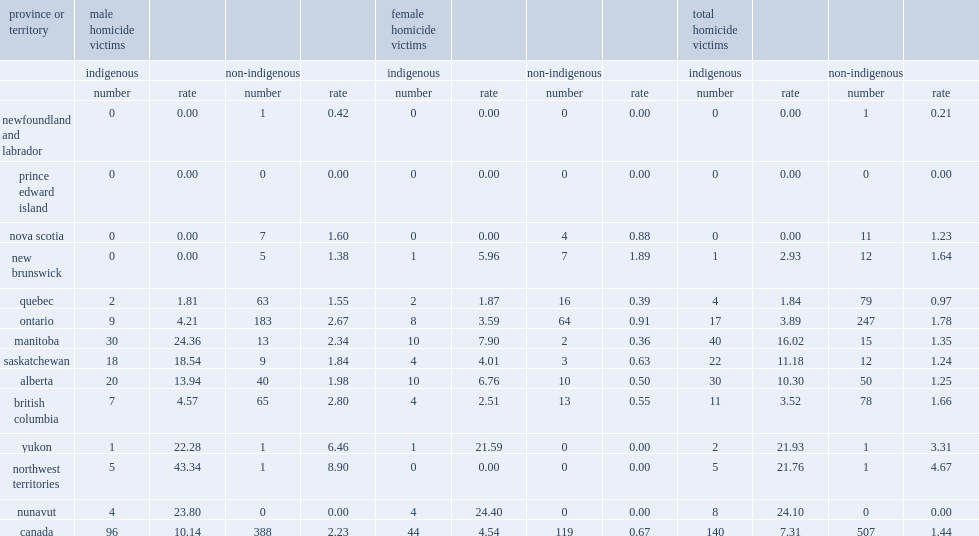What was the percentage of indigenous peoples accounting for all homicide victims? 0.216383. What was the number of male indigenous victims of homicide reported by police in 2018 and female respectively? 96.0 44.0. Which province had the highest rate of indigenous homicide victims in 2018? Manitoba. 